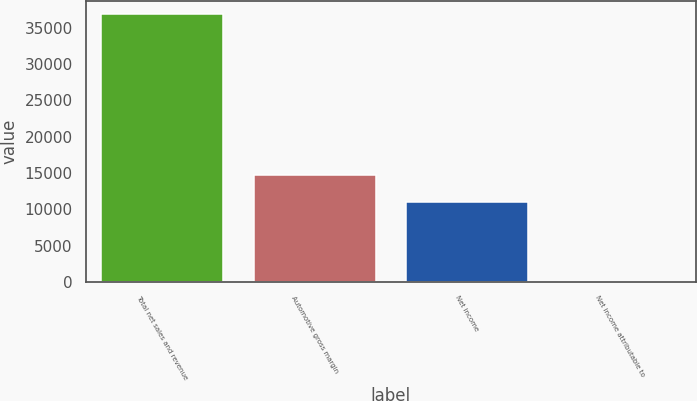Convert chart. <chart><loc_0><loc_0><loc_500><loc_500><bar_chart><fcel>Total net sales and revenue<fcel>Automotive gross margin<fcel>Net income<fcel>Net income attributable to<nl><fcel>36882<fcel>14753<fcel>11064.8<fcel>0.31<nl></chart> 